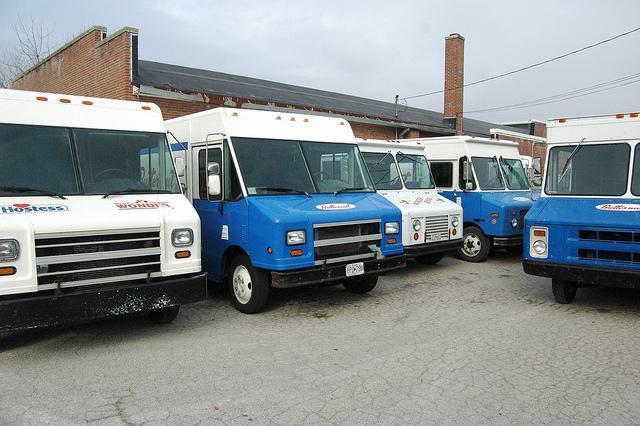How many trucks are visible?
Give a very brief answer. 5. How many people are wearing a red shirt?
Give a very brief answer. 0. 